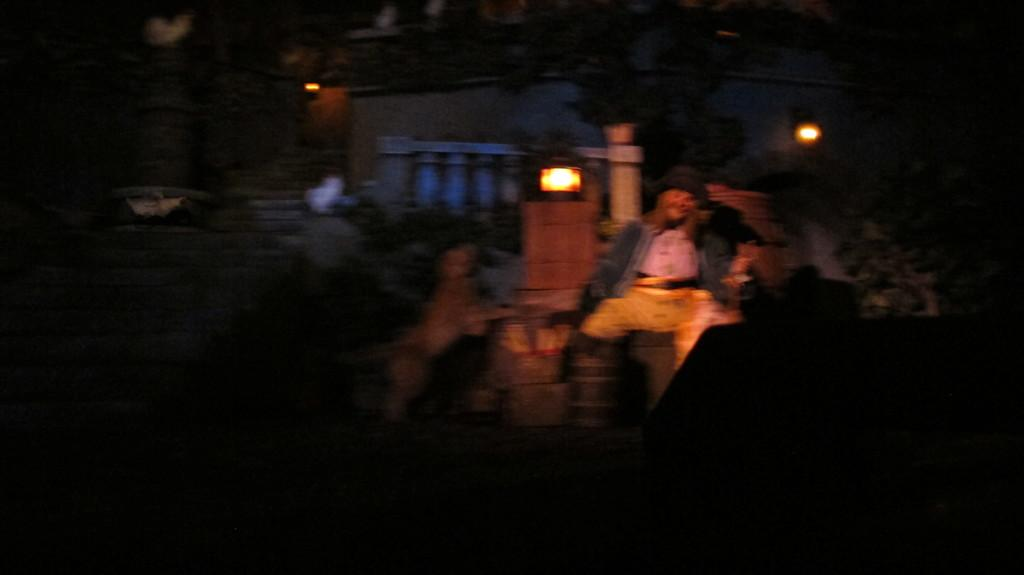What can be seen in the image that provides illumination? There are lights in the image. Who or what is the main focus of the image? There is a person in the center of the image. How would you describe the overall quality of the image? The image is blurry. What is the general lighting condition in the image? The image is dark. What type of crime is being committed in the image? There is no indication of any crime being committed in the image; it features lights, a person, and a blurry, dark appearance. What suggestion is being made by the person in the image? There is no suggestion being made by the person in the image, as the image is blurry and the person's actions or expressions cannot be clearly discerned. 